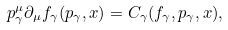<formula> <loc_0><loc_0><loc_500><loc_500>p _ { \gamma } ^ { \mu } \partial _ { \mu } f _ { \gamma } ( p _ { \gamma } , x ) = C _ { \gamma } ( f _ { \gamma } , p _ { \gamma } , x ) ,</formula> 